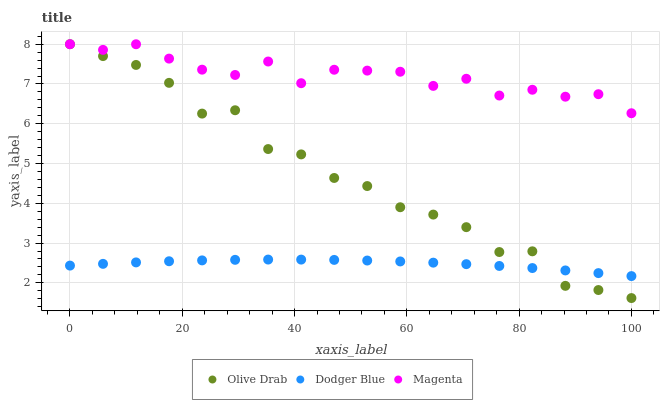Does Dodger Blue have the minimum area under the curve?
Answer yes or no. Yes. Does Magenta have the maximum area under the curve?
Answer yes or no. Yes. Does Olive Drab have the minimum area under the curve?
Answer yes or no. No. Does Olive Drab have the maximum area under the curve?
Answer yes or no. No. Is Dodger Blue the smoothest?
Answer yes or no. Yes. Is Olive Drab the roughest?
Answer yes or no. Yes. Is Olive Drab the smoothest?
Answer yes or no. No. Is Dodger Blue the roughest?
Answer yes or no. No. Does Olive Drab have the lowest value?
Answer yes or no. Yes. Does Dodger Blue have the lowest value?
Answer yes or no. No. Does Olive Drab have the highest value?
Answer yes or no. Yes. Does Dodger Blue have the highest value?
Answer yes or no. No. Is Dodger Blue less than Magenta?
Answer yes or no. Yes. Is Magenta greater than Dodger Blue?
Answer yes or no. Yes. Does Magenta intersect Olive Drab?
Answer yes or no. Yes. Is Magenta less than Olive Drab?
Answer yes or no. No. Is Magenta greater than Olive Drab?
Answer yes or no. No. Does Dodger Blue intersect Magenta?
Answer yes or no. No. 